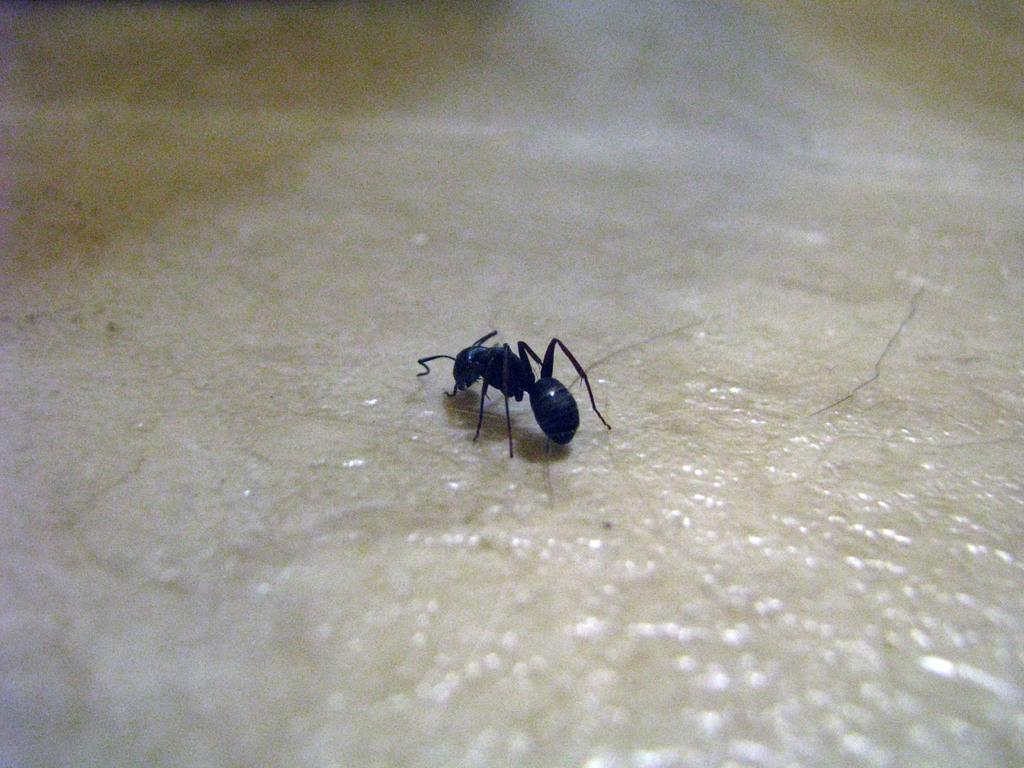Please provide a concise description of this image. This image consists of an ant. It is in black color. 